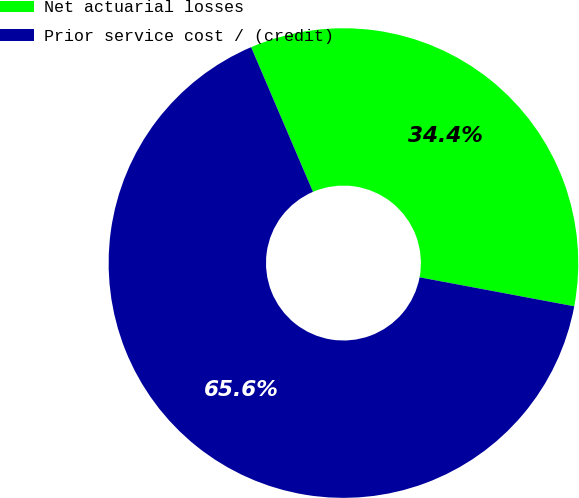<chart> <loc_0><loc_0><loc_500><loc_500><pie_chart><fcel>Net actuarial losses<fcel>Prior service cost / (credit)<nl><fcel>34.38%<fcel>65.62%<nl></chart> 